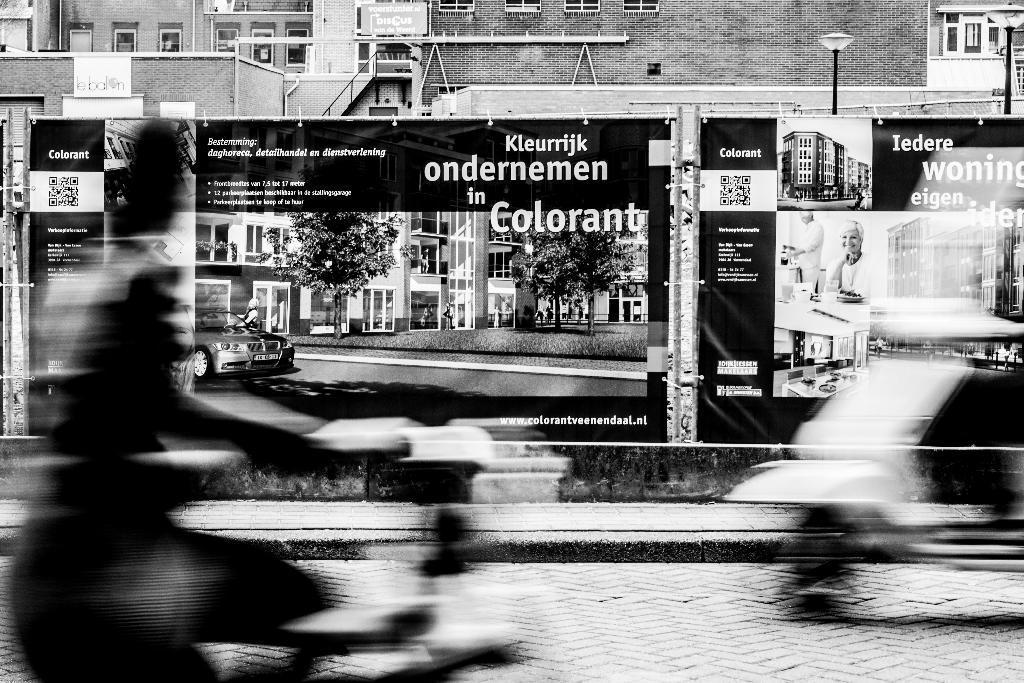Please provide a concise description of this image. This image is clicked outside. At the bottom, there is a road. On the left, there is a person. On the right, there is a scooter. In the background, there are buildings and hoardings. 